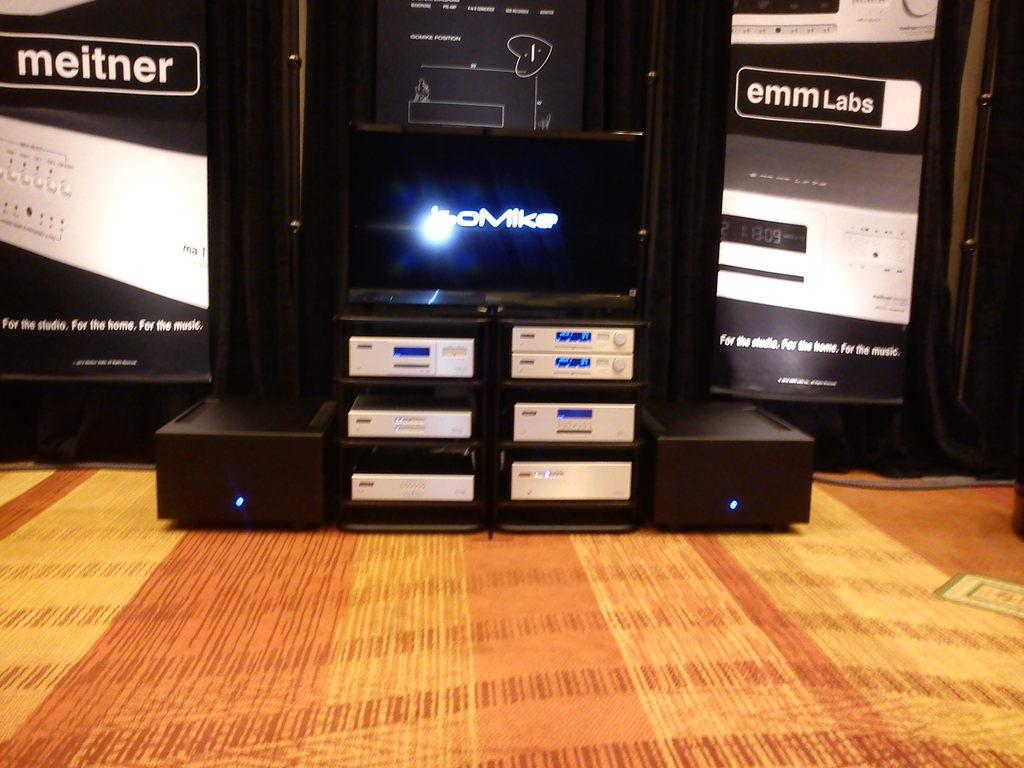Provide a one-sentence caption for the provided image. A display of high end electronic equipment contains some Meitner product. 